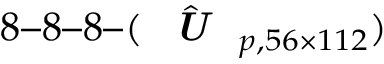Convert formula to latex. <formula><loc_0><loc_0><loc_500><loc_500>8 8 8 ( \hat { U } _ { p , 5 6 \times 1 1 2 } )</formula> 